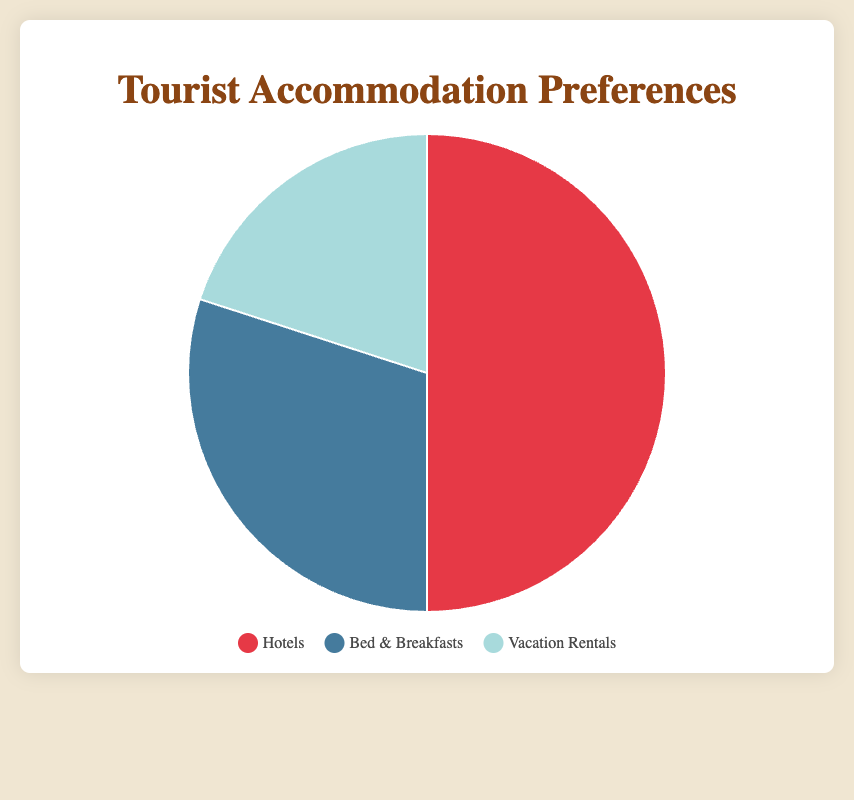What is the most preferred type of accommodation among tourists? Based on the pie chart, the segment representing Hotels occupies 50% of the chart, which is the largest percentage compared to Bed & Breakfasts and Vacation Rentals.
Answer: Hotels Which type of accommodation is least preferred by tourists? The pie chart shows that Vacation Rentals have the smallest segment, representing 20% of the preferences.
Answer: Vacation Rentals How much more popular are Hotels compared to Vacation Rentals? According to the chart, Hotels have a preference rate of 50%, whereas Vacation Rentals have 20%. The difference is 50% - 20% = 30%.
Answer: 30% What percentage of tourists prefer either Hotels or Bed & Breakfasts? Hotels have a preference rate of 50%, and Bed & Breakfasts have 30%. Adding these percentages gives 50% + 30% = 80%.
Answer: 80% If there are 1,000 tourists, how many would prefer Bed & Breakfasts? The pie chart indicates that 30% of tourists prefer Bed & Breakfasts. To find the number out of 1,000 tourists, calculate 30% of 1,000: 0.30 * 1000 = 300.
Answer: 300 Which color represents Vacation Rentals in the pie chart? The legend shows a light blue color corresponding to Vacation Rentals.
Answer: light blue How do the preferences for Bed & Breakfasts compare to those for Vacation Rentals? Bed & Breakfasts have a preference rate of 30%, while Vacation Rentals have 20%. Bed & Breakfasts are preferred 10% more than Vacation Rentals.
Answer: 10% What is the combined percentage of tourists that prefer accommodations other than Hotels? Bed & Breakfasts are preferred by 30% and Vacation Rentals by 20%, so combined, they represent 30% + 20% = 50%.
Answer: 50% How much less popular are Bed & Breakfasts compared to Hotels? According to the chart, Hotels are preferred by 50% of tourists, while Bed & Breakfasts are preferred by 30%. The difference is 50% - 30% = 20%.
Answer: 20% What is the ratio of tourists preferring Hotels to those preferring Vacation Rentals? The pie chart shows that Hotels have a preference rate of 50% and Vacation Rentals have 20%. The ratio is 50:20, which simplifies to 5:2.
Answer: 5:2 